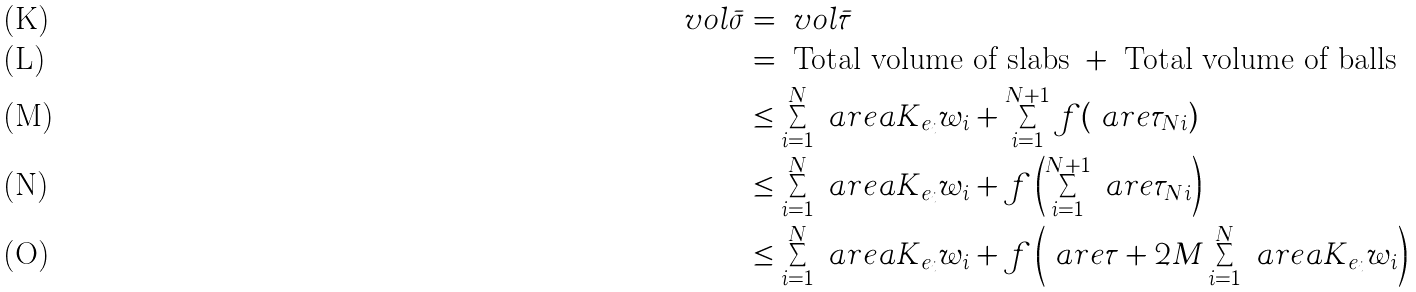Convert formula to latex. <formula><loc_0><loc_0><loc_500><loc_500>\ v o l { \bar { \sigma } } & = \ v o l { \bar { \tau } } \\ & = \text { Total volume of slabs } + \text { Total volume of balls } \\ & \leq \sum _ { i = 1 } ^ { N } \ a r e a { K _ { e _ { i } } } { w _ { i } } + \sum _ { i = 1 } ^ { N + 1 } f ( \ a r e { \tau _ { N i } } ) \\ & \leq \sum _ { i = 1 } ^ { N } \ a r e a { K _ { e _ { i } } } { w _ { i } } + f \left ( \sum _ { i = 1 } ^ { N + 1 } \ a r e { \tau _ { N i } } \right ) \\ & \leq \sum _ { i = 1 } ^ { N } \ a r e a { K _ { e _ { i } } } { w _ { i } } + f \left ( \ a r e { \tau } + 2 M \sum _ { i = 1 } ^ { N } \ a r e a { K _ { e _ { i } } } { w _ { i } } \right )</formula> 